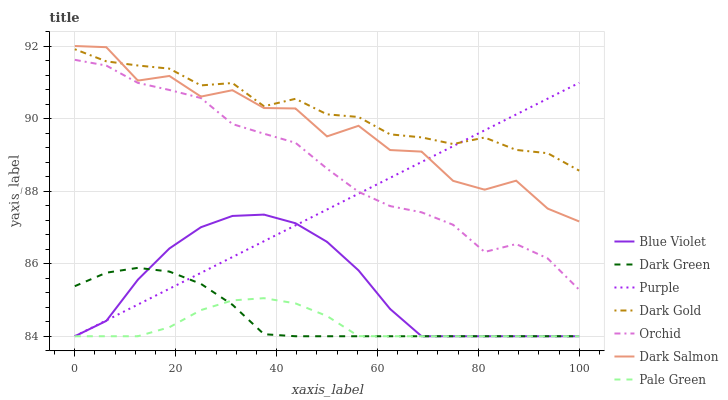Does Pale Green have the minimum area under the curve?
Answer yes or no. Yes. Does Dark Gold have the maximum area under the curve?
Answer yes or no. Yes. Does Purple have the minimum area under the curve?
Answer yes or no. No. Does Purple have the maximum area under the curve?
Answer yes or no. No. Is Purple the smoothest?
Answer yes or no. Yes. Is Dark Salmon the roughest?
Answer yes or no. Yes. Is Dark Salmon the smoothest?
Answer yes or no. No. Is Purple the roughest?
Answer yes or no. No. Does Purple have the lowest value?
Answer yes or no. Yes. Does Dark Salmon have the lowest value?
Answer yes or no. No. Does Dark Salmon have the highest value?
Answer yes or no. Yes. Does Purple have the highest value?
Answer yes or no. No. Is Pale Green less than Dark Gold?
Answer yes or no. Yes. Is Orchid greater than Pale Green?
Answer yes or no. Yes. Does Purple intersect Blue Violet?
Answer yes or no. Yes. Is Purple less than Blue Violet?
Answer yes or no. No. Is Purple greater than Blue Violet?
Answer yes or no. No. Does Pale Green intersect Dark Gold?
Answer yes or no. No. 